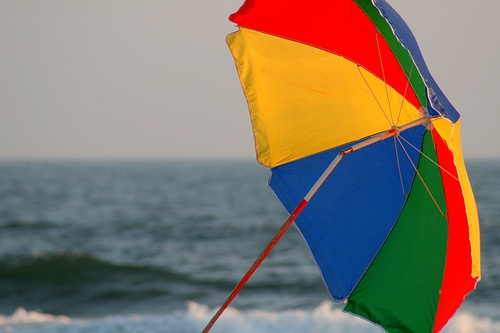Describe the objects in this image and their specific colors. I can see a umbrella in darkgray, orange, darkgreen, red, and darkblue tones in this image. 